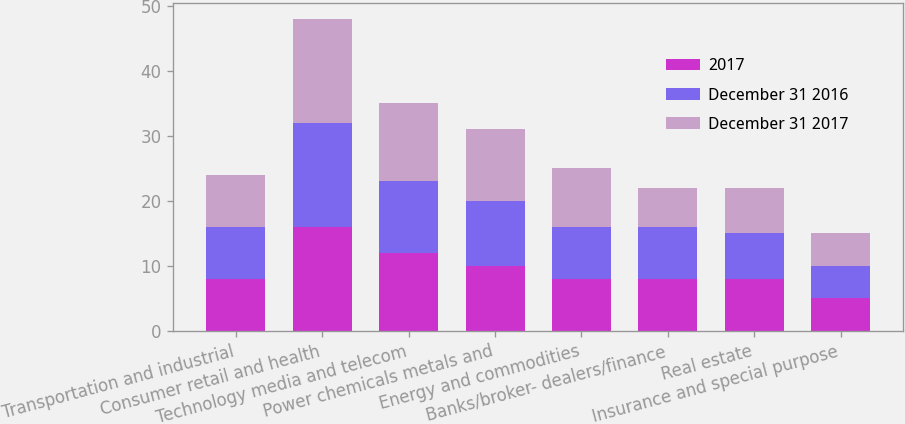Convert chart. <chart><loc_0><loc_0><loc_500><loc_500><stacked_bar_chart><ecel><fcel>Transportation and industrial<fcel>Consumer retail and health<fcel>Technology media and telecom<fcel>Power chemicals metals and<fcel>Energy and commodities<fcel>Banks/broker- dealers/finance<fcel>Real estate<fcel>Insurance and special purpose<nl><fcel>2017<fcel>8<fcel>16<fcel>12<fcel>10<fcel>8<fcel>8<fcel>8<fcel>5<nl><fcel>December 31 2016<fcel>8<fcel>16<fcel>11<fcel>10<fcel>8<fcel>8<fcel>7<fcel>5<nl><fcel>December 31 2017<fcel>8<fcel>16<fcel>12<fcel>11<fcel>9<fcel>6<fcel>7<fcel>5<nl></chart> 